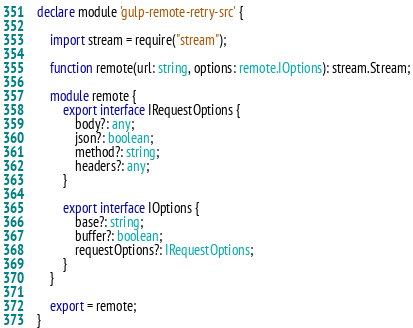Convert code to text. <code><loc_0><loc_0><loc_500><loc_500><_TypeScript_>declare module 'gulp-remote-retry-src' {

	import stream = require("stream");

	function remote(url: string, options: remote.IOptions): stream.Stream;

	module remote {
		export interface IRequestOptions {
			body?: any;
			json?: boolean;
			method?: string;
			headers?: any;
		}

		export interface IOptions {
			base?: string;
			buffer?: boolean;
			requestOptions?: IRequestOptions;
		}
	}

	export = remote;
}
</code> 